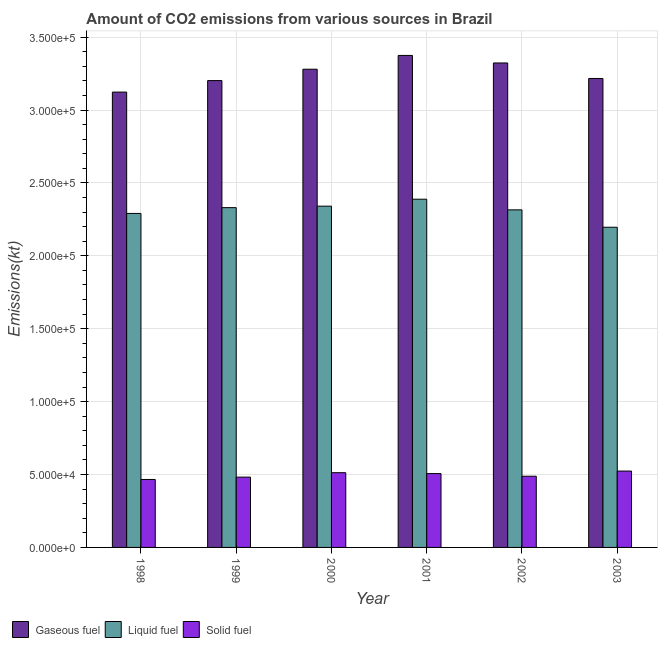Are the number of bars on each tick of the X-axis equal?
Provide a succinct answer. Yes. How many bars are there on the 3rd tick from the left?
Your answer should be compact. 3. In how many cases, is the number of bars for a given year not equal to the number of legend labels?
Offer a very short reply. 0. What is the amount of co2 emissions from solid fuel in 2001?
Give a very brief answer. 5.06e+04. Across all years, what is the maximum amount of co2 emissions from solid fuel?
Provide a succinct answer. 5.24e+04. Across all years, what is the minimum amount of co2 emissions from liquid fuel?
Ensure brevity in your answer.  2.20e+05. In which year was the amount of co2 emissions from gaseous fuel maximum?
Your answer should be very brief. 2001. What is the total amount of co2 emissions from solid fuel in the graph?
Make the answer very short. 2.98e+05. What is the difference between the amount of co2 emissions from solid fuel in 2000 and that in 2003?
Your answer should be compact. -1129.44. What is the difference between the amount of co2 emissions from gaseous fuel in 2000 and the amount of co2 emissions from solid fuel in 2001?
Your response must be concise. -9449.86. What is the average amount of co2 emissions from solid fuel per year?
Offer a terse response. 4.97e+04. In the year 2000, what is the difference between the amount of co2 emissions from liquid fuel and amount of co2 emissions from solid fuel?
Your response must be concise. 0. What is the ratio of the amount of co2 emissions from liquid fuel in 2000 to that in 2001?
Give a very brief answer. 0.98. Is the amount of co2 emissions from gaseous fuel in 2000 less than that in 2003?
Offer a very short reply. No. What is the difference between the highest and the second highest amount of co2 emissions from solid fuel?
Your response must be concise. 1129.44. What is the difference between the highest and the lowest amount of co2 emissions from liquid fuel?
Offer a very short reply. 1.92e+04. In how many years, is the amount of co2 emissions from gaseous fuel greater than the average amount of co2 emissions from gaseous fuel taken over all years?
Make the answer very short. 3. What does the 3rd bar from the left in 2002 represents?
Make the answer very short. Solid fuel. What does the 3rd bar from the right in 1998 represents?
Offer a very short reply. Gaseous fuel. How many bars are there?
Your answer should be very brief. 18. Are all the bars in the graph horizontal?
Your answer should be compact. No. Are the values on the major ticks of Y-axis written in scientific E-notation?
Keep it short and to the point. Yes. How many legend labels are there?
Provide a short and direct response. 3. What is the title of the graph?
Keep it short and to the point. Amount of CO2 emissions from various sources in Brazil. What is the label or title of the Y-axis?
Give a very brief answer. Emissions(kt). What is the Emissions(kt) in Gaseous fuel in 1998?
Provide a succinct answer. 3.12e+05. What is the Emissions(kt) of Liquid fuel in 1998?
Make the answer very short. 2.29e+05. What is the Emissions(kt) of Solid fuel in 1998?
Offer a very short reply. 4.66e+04. What is the Emissions(kt) in Gaseous fuel in 1999?
Make the answer very short. 3.20e+05. What is the Emissions(kt) of Liquid fuel in 1999?
Provide a short and direct response. 2.33e+05. What is the Emissions(kt) of Solid fuel in 1999?
Make the answer very short. 4.82e+04. What is the Emissions(kt) of Gaseous fuel in 2000?
Provide a succinct answer. 3.28e+05. What is the Emissions(kt) of Liquid fuel in 2000?
Your answer should be compact. 2.34e+05. What is the Emissions(kt) of Solid fuel in 2000?
Provide a succinct answer. 5.12e+04. What is the Emissions(kt) in Gaseous fuel in 2001?
Provide a short and direct response. 3.37e+05. What is the Emissions(kt) in Liquid fuel in 2001?
Provide a short and direct response. 2.39e+05. What is the Emissions(kt) in Solid fuel in 2001?
Offer a terse response. 5.06e+04. What is the Emissions(kt) of Gaseous fuel in 2002?
Your response must be concise. 3.32e+05. What is the Emissions(kt) of Liquid fuel in 2002?
Make the answer very short. 2.32e+05. What is the Emissions(kt) of Solid fuel in 2002?
Ensure brevity in your answer.  4.88e+04. What is the Emissions(kt) of Gaseous fuel in 2003?
Provide a succinct answer. 3.22e+05. What is the Emissions(kt) in Liquid fuel in 2003?
Ensure brevity in your answer.  2.20e+05. What is the Emissions(kt) of Solid fuel in 2003?
Make the answer very short. 5.24e+04. Across all years, what is the maximum Emissions(kt) of Gaseous fuel?
Your answer should be very brief. 3.37e+05. Across all years, what is the maximum Emissions(kt) of Liquid fuel?
Your response must be concise. 2.39e+05. Across all years, what is the maximum Emissions(kt) in Solid fuel?
Make the answer very short. 5.24e+04. Across all years, what is the minimum Emissions(kt) of Gaseous fuel?
Offer a very short reply. 3.12e+05. Across all years, what is the minimum Emissions(kt) in Liquid fuel?
Make the answer very short. 2.20e+05. Across all years, what is the minimum Emissions(kt) of Solid fuel?
Your answer should be compact. 4.66e+04. What is the total Emissions(kt) of Gaseous fuel in the graph?
Give a very brief answer. 1.95e+06. What is the total Emissions(kt) of Liquid fuel in the graph?
Your response must be concise. 1.39e+06. What is the total Emissions(kt) of Solid fuel in the graph?
Make the answer very short. 2.98e+05. What is the difference between the Emissions(kt) of Gaseous fuel in 1998 and that in 1999?
Give a very brief answer. -7884.05. What is the difference between the Emissions(kt) of Liquid fuel in 1998 and that in 1999?
Ensure brevity in your answer.  -3971.36. What is the difference between the Emissions(kt) in Solid fuel in 1998 and that in 1999?
Give a very brief answer. -1609.81. What is the difference between the Emissions(kt) of Gaseous fuel in 1998 and that in 2000?
Ensure brevity in your answer.  -1.57e+04. What is the difference between the Emissions(kt) in Liquid fuel in 1998 and that in 2000?
Keep it short and to the point. -4979.79. What is the difference between the Emissions(kt) in Solid fuel in 1998 and that in 2000?
Offer a very short reply. -4642.42. What is the difference between the Emissions(kt) in Gaseous fuel in 1998 and that in 2001?
Provide a short and direct response. -2.51e+04. What is the difference between the Emissions(kt) in Liquid fuel in 1998 and that in 2001?
Your response must be concise. -9754.22. What is the difference between the Emissions(kt) in Solid fuel in 1998 and that in 2001?
Keep it short and to the point. -4037.37. What is the difference between the Emissions(kt) of Gaseous fuel in 1998 and that in 2002?
Provide a succinct answer. -2.00e+04. What is the difference between the Emissions(kt) of Liquid fuel in 1998 and that in 2002?
Provide a short and direct response. -2449.56. What is the difference between the Emissions(kt) of Solid fuel in 1998 and that in 2002?
Make the answer very short. -2218.53. What is the difference between the Emissions(kt) of Gaseous fuel in 1998 and that in 2003?
Your answer should be very brief. -9332.51. What is the difference between the Emissions(kt) of Liquid fuel in 1998 and that in 2003?
Keep it short and to the point. 9471.86. What is the difference between the Emissions(kt) of Solid fuel in 1998 and that in 2003?
Your answer should be very brief. -5771.86. What is the difference between the Emissions(kt) of Gaseous fuel in 1999 and that in 2000?
Keep it short and to the point. -7810.71. What is the difference between the Emissions(kt) in Liquid fuel in 1999 and that in 2000?
Keep it short and to the point. -1008.42. What is the difference between the Emissions(kt) of Solid fuel in 1999 and that in 2000?
Your answer should be very brief. -3032.61. What is the difference between the Emissions(kt) in Gaseous fuel in 1999 and that in 2001?
Keep it short and to the point. -1.73e+04. What is the difference between the Emissions(kt) in Liquid fuel in 1999 and that in 2001?
Keep it short and to the point. -5782.86. What is the difference between the Emissions(kt) in Solid fuel in 1999 and that in 2001?
Make the answer very short. -2427.55. What is the difference between the Emissions(kt) of Gaseous fuel in 1999 and that in 2002?
Ensure brevity in your answer.  -1.21e+04. What is the difference between the Emissions(kt) of Liquid fuel in 1999 and that in 2002?
Your response must be concise. 1521.81. What is the difference between the Emissions(kt) in Solid fuel in 1999 and that in 2002?
Offer a terse response. -608.72. What is the difference between the Emissions(kt) in Gaseous fuel in 1999 and that in 2003?
Keep it short and to the point. -1448.46. What is the difference between the Emissions(kt) of Liquid fuel in 1999 and that in 2003?
Give a very brief answer. 1.34e+04. What is the difference between the Emissions(kt) of Solid fuel in 1999 and that in 2003?
Provide a short and direct response. -4162.05. What is the difference between the Emissions(kt) in Gaseous fuel in 2000 and that in 2001?
Your response must be concise. -9449.86. What is the difference between the Emissions(kt) in Liquid fuel in 2000 and that in 2001?
Offer a very short reply. -4774.43. What is the difference between the Emissions(kt) of Solid fuel in 2000 and that in 2001?
Give a very brief answer. 605.05. What is the difference between the Emissions(kt) in Gaseous fuel in 2000 and that in 2002?
Provide a succinct answer. -4283.06. What is the difference between the Emissions(kt) of Liquid fuel in 2000 and that in 2002?
Offer a terse response. 2530.23. What is the difference between the Emissions(kt) in Solid fuel in 2000 and that in 2002?
Make the answer very short. 2423.89. What is the difference between the Emissions(kt) in Gaseous fuel in 2000 and that in 2003?
Your response must be concise. 6362.24. What is the difference between the Emissions(kt) of Liquid fuel in 2000 and that in 2003?
Your answer should be compact. 1.45e+04. What is the difference between the Emissions(kt) of Solid fuel in 2000 and that in 2003?
Offer a terse response. -1129.44. What is the difference between the Emissions(kt) in Gaseous fuel in 2001 and that in 2002?
Offer a terse response. 5166.8. What is the difference between the Emissions(kt) in Liquid fuel in 2001 and that in 2002?
Give a very brief answer. 7304.66. What is the difference between the Emissions(kt) in Solid fuel in 2001 and that in 2002?
Provide a short and direct response. 1818.83. What is the difference between the Emissions(kt) in Gaseous fuel in 2001 and that in 2003?
Provide a short and direct response. 1.58e+04. What is the difference between the Emissions(kt) of Liquid fuel in 2001 and that in 2003?
Offer a very short reply. 1.92e+04. What is the difference between the Emissions(kt) of Solid fuel in 2001 and that in 2003?
Make the answer very short. -1734.49. What is the difference between the Emissions(kt) in Gaseous fuel in 2002 and that in 2003?
Your response must be concise. 1.06e+04. What is the difference between the Emissions(kt) of Liquid fuel in 2002 and that in 2003?
Offer a terse response. 1.19e+04. What is the difference between the Emissions(kt) of Solid fuel in 2002 and that in 2003?
Make the answer very short. -3553.32. What is the difference between the Emissions(kt) in Gaseous fuel in 1998 and the Emissions(kt) in Liquid fuel in 1999?
Your response must be concise. 7.93e+04. What is the difference between the Emissions(kt) of Gaseous fuel in 1998 and the Emissions(kt) of Solid fuel in 1999?
Offer a terse response. 2.64e+05. What is the difference between the Emissions(kt) of Liquid fuel in 1998 and the Emissions(kt) of Solid fuel in 1999?
Make the answer very short. 1.81e+05. What is the difference between the Emissions(kt) in Gaseous fuel in 1998 and the Emissions(kt) in Liquid fuel in 2000?
Provide a succinct answer. 7.82e+04. What is the difference between the Emissions(kt) of Gaseous fuel in 1998 and the Emissions(kt) of Solid fuel in 2000?
Your answer should be very brief. 2.61e+05. What is the difference between the Emissions(kt) of Liquid fuel in 1998 and the Emissions(kt) of Solid fuel in 2000?
Your answer should be compact. 1.78e+05. What is the difference between the Emissions(kt) in Gaseous fuel in 1998 and the Emissions(kt) in Liquid fuel in 2001?
Provide a short and direct response. 7.35e+04. What is the difference between the Emissions(kt) in Gaseous fuel in 1998 and the Emissions(kt) in Solid fuel in 2001?
Provide a short and direct response. 2.62e+05. What is the difference between the Emissions(kt) of Liquid fuel in 1998 and the Emissions(kt) of Solid fuel in 2001?
Your response must be concise. 1.78e+05. What is the difference between the Emissions(kt) in Gaseous fuel in 1998 and the Emissions(kt) in Liquid fuel in 2002?
Offer a terse response. 8.08e+04. What is the difference between the Emissions(kt) of Gaseous fuel in 1998 and the Emissions(kt) of Solid fuel in 2002?
Your answer should be compact. 2.63e+05. What is the difference between the Emissions(kt) of Liquid fuel in 1998 and the Emissions(kt) of Solid fuel in 2002?
Make the answer very short. 1.80e+05. What is the difference between the Emissions(kt) of Gaseous fuel in 1998 and the Emissions(kt) of Liquid fuel in 2003?
Ensure brevity in your answer.  9.27e+04. What is the difference between the Emissions(kt) of Gaseous fuel in 1998 and the Emissions(kt) of Solid fuel in 2003?
Provide a short and direct response. 2.60e+05. What is the difference between the Emissions(kt) of Liquid fuel in 1998 and the Emissions(kt) of Solid fuel in 2003?
Provide a short and direct response. 1.77e+05. What is the difference between the Emissions(kt) of Gaseous fuel in 1999 and the Emissions(kt) of Liquid fuel in 2000?
Keep it short and to the point. 8.61e+04. What is the difference between the Emissions(kt) in Gaseous fuel in 1999 and the Emissions(kt) in Solid fuel in 2000?
Ensure brevity in your answer.  2.69e+05. What is the difference between the Emissions(kt) in Liquid fuel in 1999 and the Emissions(kt) in Solid fuel in 2000?
Keep it short and to the point. 1.82e+05. What is the difference between the Emissions(kt) in Gaseous fuel in 1999 and the Emissions(kt) in Liquid fuel in 2001?
Ensure brevity in your answer.  8.14e+04. What is the difference between the Emissions(kt) in Gaseous fuel in 1999 and the Emissions(kt) in Solid fuel in 2001?
Keep it short and to the point. 2.70e+05. What is the difference between the Emissions(kt) in Liquid fuel in 1999 and the Emissions(kt) in Solid fuel in 2001?
Offer a terse response. 1.82e+05. What is the difference between the Emissions(kt) of Gaseous fuel in 1999 and the Emissions(kt) of Liquid fuel in 2002?
Provide a succinct answer. 8.87e+04. What is the difference between the Emissions(kt) of Gaseous fuel in 1999 and the Emissions(kt) of Solid fuel in 2002?
Your answer should be very brief. 2.71e+05. What is the difference between the Emissions(kt) of Liquid fuel in 1999 and the Emissions(kt) of Solid fuel in 2002?
Offer a very short reply. 1.84e+05. What is the difference between the Emissions(kt) of Gaseous fuel in 1999 and the Emissions(kt) of Liquid fuel in 2003?
Offer a very short reply. 1.01e+05. What is the difference between the Emissions(kt) of Gaseous fuel in 1999 and the Emissions(kt) of Solid fuel in 2003?
Your answer should be very brief. 2.68e+05. What is the difference between the Emissions(kt) of Liquid fuel in 1999 and the Emissions(kt) of Solid fuel in 2003?
Keep it short and to the point. 1.81e+05. What is the difference between the Emissions(kt) in Gaseous fuel in 2000 and the Emissions(kt) in Liquid fuel in 2001?
Keep it short and to the point. 8.92e+04. What is the difference between the Emissions(kt) in Gaseous fuel in 2000 and the Emissions(kt) in Solid fuel in 2001?
Provide a succinct answer. 2.77e+05. What is the difference between the Emissions(kt) in Liquid fuel in 2000 and the Emissions(kt) in Solid fuel in 2001?
Give a very brief answer. 1.83e+05. What is the difference between the Emissions(kt) in Gaseous fuel in 2000 and the Emissions(kt) in Liquid fuel in 2002?
Make the answer very short. 9.65e+04. What is the difference between the Emissions(kt) of Gaseous fuel in 2000 and the Emissions(kt) of Solid fuel in 2002?
Give a very brief answer. 2.79e+05. What is the difference between the Emissions(kt) of Liquid fuel in 2000 and the Emissions(kt) of Solid fuel in 2002?
Your answer should be compact. 1.85e+05. What is the difference between the Emissions(kt) in Gaseous fuel in 2000 and the Emissions(kt) in Liquid fuel in 2003?
Provide a succinct answer. 1.08e+05. What is the difference between the Emissions(kt) in Gaseous fuel in 2000 and the Emissions(kt) in Solid fuel in 2003?
Give a very brief answer. 2.76e+05. What is the difference between the Emissions(kt) in Liquid fuel in 2000 and the Emissions(kt) in Solid fuel in 2003?
Your response must be concise. 1.82e+05. What is the difference between the Emissions(kt) of Gaseous fuel in 2001 and the Emissions(kt) of Liquid fuel in 2002?
Offer a terse response. 1.06e+05. What is the difference between the Emissions(kt) in Gaseous fuel in 2001 and the Emissions(kt) in Solid fuel in 2002?
Your response must be concise. 2.89e+05. What is the difference between the Emissions(kt) in Liquid fuel in 2001 and the Emissions(kt) in Solid fuel in 2002?
Keep it short and to the point. 1.90e+05. What is the difference between the Emissions(kt) of Gaseous fuel in 2001 and the Emissions(kt) of Liquid fuel in 2003?
Your response must be concise. 1.18e+05. What is the difference between the Emissions(kt) of Gaseous fuel in 2001 and the Emissions(kt) of Solid fuel in 2003?
Offer a very short reply. 2.85e+05. What is the difference between the Emissions(kt) of Liquid fuel in 2001 and the Emissions(kt) of Solid fuel in 2003?
Provide a succinct answer. 1.86e+05. What is the difference between the Emissions(kt) of Gaseous fuel in 2002 and the Emissions(kt) of Liquid fuel in 2003?
Your response must be concise. 1.13e+05. What is the difference between the Emissions(kt) of Gaseous fuel in 2002 and the Emissions(kt) of Solid fuel in 2003?
Provide a short and direct response. 2.80e+05. What is the difference between the Emissions(kt) of Liquid fuel in 2002 and the Emissions(kt) of Solid fuel in 2003?
Provide a short and direct response. 1.79e+05. What is the average Emissions(kt) of Gaseous fuel per year?
Provide a succinct answer. 3.25e+05. What is the average Emissions(kt) in Liquid fuel per year?
Provide a succinct answer. 2.31e+05. What is the average Emissions(kt) in Solid fuel per year?
Provide a short and direct response. 4.97e+04. In the year 1998, what is the difference between the Emissions(kt) of Gaseous fuel and Emissions(kt) of Liquid fuel?
Your response must be concise. 8.32e+04. In the year 1998, what is the difference between the Emissions(kt) of Gaseous fuel and Emissions(kt) of Solid fuel?
Ensure brevity in your answer.  2.66e+05. In the year 1998, what is the difference between the Emissions(kt) in Liquid fuel and Emissions(kt) in Solid fuel?
Give a very brief answer. 1.82e+05. In the year 1999, what is the difference between the Emissions(kt) in Gaseous fuel and Emissions(kt) in Liquid fuel?
Your response must be concise. 8.71e+04. In the year 1999, what is the difference between the Emissions(kt) of Gaseous fuel and Emissions(kt) of Solid fuel?
Offer a terse response. 2.72e+05. In the year 1999, what is the difference between the Emissions(kt) in Liquid fuel and Emissions(kt) in Solid fuel?
Give a very brief answer. 1.85e+05. In the year 2000, what is the difference between the Emissions(kt) in Gaseous fuel and Emissions(kt) in Liquid fuel?
Provide a short and direct response. 9.39e+04. In the year 2000, what is the difference between the Emissions(kt) of Gaseous fuel and Emissions(kt) of Solid fuel?
Provide a succinct answer. 2.77e+05. In the year 2000, what is the difference between the Emissions(kt) in Liquid fuel and Emissions(kt) in Solid fuel?
Keep it short and to the point. 1.83e+05. In the year 2001, what is the difference between the Emissions(kt) in Gaseous fuel and Emissions(kt) in Liquid fuel?
Make the answer very short. 9.86e+04. In the year 2001, what is the difference between the Emissions(kt) in Gaseous fuel and Emissions(kt) in Solid fuel?
Offer a terse response. 2.87e+05. In the year 2001, what is the difference between the Emissions(kt) of Liquid fuel and Emissions(kt) of Solid fuel?
Make the answer very short. 1.88e+05. In the year 2002, what is the difference between the Emissions(kt) in Gaseous fuel and Emissions(kt) in Liquid fuel?
Your response must be concise. 1.01e+05. In the year 2002, what is the difference between the Emissions(kt) of Gaseous fuel and Emissions(kt) of Solid fuel?
Make the answer very short. 2.83e+05. In the year 2002, what is the difference between the Emissions(kt) in Liquid fuel and Emissions(kt) in Solid fuel?
Your answer should be very brief. 1.83e+05. In the year 2003, what is the difference between the Emissions(kt) of Gaseous fuel and Emissions(kt) of Liquid fuel?
Give a very brief answer. 1.02e+05. In the year 2003, what is the difference between the Emissions(kt) of Gaseous fuel and Emissions(kt) of Solid fuel?
Provide a succinct answer. 2.69e+05. In the year 2003, what is the difference between the Emissions(kt) in Liquid fuel and Emissions(kt) in Solid fuel?
Offer a very short reply. 1.67e+05. What is the ratio of the Emissions(kt) of Gaseous fuel in 1998 to that in 1999?
Your answer should be compact. 0.98. What is the ratio of the Emissions(kt) of Liquid fuel in 1998 to that in 1999?
Your answer should be compact. 0.98. What is the ratio of the Emissions(kt) of Solid fuel in 1998 to that in 1999?
Your answer should be compact. 0.97. What is the ratio of the Emissions(kt) in Gaseous fuel in 1998 to that in 2000?
Provide a short and direct response. 0.95. What is the ratio of the Emissions(kt) in Liquid fuel in 1998 to that in 2000?
Make the answer very short. 0.98. What is the ratio of the Emissions(kt) in Solid fuel in 1998 to that in 2000?
Ensure brevity in your answer.  0.91. What is the ratio of the Emissions(kt) in Gaseous fuel in 1998 to that in 2001?
Provide a succinct answer. 0.93. What is the ratio of the Emissions(kt) in Liquid fuel in 1998 to that in 2001?
Give a very brief answer. 0.96. What is the ratio of the Emissions(kt) of Solid fuel in 1998 to that in 2001?
Your answer should be compact. 0.92. What is the ratio of the Emissions(kt) of Gaseous fuel in 1998 to that in 2002?
Give a very brief answer. 0.94. What is the ratio of the Emissions(kt) in Solid fuel in 1998 to that in 2002?
Ensure brevity in your answer.  0.95. What is the ratio of the Emissions(kt) in Gaseous fuel in 1998 to that in 2003?
Your response must be concise. 0.97. What is the ratio of the Emissions(kt) of Liquid fuel in 1998 to that in 2003?
Provide a succinct answer. 1.04. What is the ratio of the Emissions(kt) of Solid fuel in 1998 to that in 2003?
Your response must be concise. 0.89. What is the ratio of the Emissions(kt) in Gaseous fuel in 1999 to that in 2000?
Your answer should be compact. 0.98. What is the ratio of the Emissions(kt) of Solid fuel in 1999 to that in 2000?
Keep it short and to the point. 0.94. What is the ratio of the Emissions(kt) in Gaseous fuel in 1999 to that in 2001?
Provide a succinct answer. 0.95. What is the ratio of the Emissions(kt) in Liquid fuel in 1999 to that in 2001?
Give a very brief answer. 0.98. What is the ratio of the Emissions(kt) in Solid fuel in 1999 to that in 2001?
Offer a terse response. 0.95. What is the ratio of the Emissions(kt) in Gaseous fuel in 1999 to that in 2002?
Provide a short and direct response. 0.96. What is the ratio of the Emissions(kt) in Liquid fuel in 1999 to that in 2002?
Make the answer very short. 1.01. What is the ratio of the Emissions(kt) of Solid fuel in 1999 to that in 2002?
Ensure brevity in your answer.  0.99. What is the ratio of the Emissions(kt) of Liquid fuel in 1999 to that in 2003?
Keep it short and to the point. 1.06. What is the ratio of the Emissions(kt) of Solid fuel in 1999 to that in 2003?
Give a very brief answer. 0.92. What is the ratio of the Emissions(kt) in Liquid fuel in 2000 to that in 2001?
Your response must be concise. 0.98. What is the ratio of the Emissions(kt) in Solid fuel in 2000 to that in 2001?
Your answer should be compact. 1.01. What is the ratio of the Emissions(kt) in Gaseous fuel in 2000 to that in 2002?
Offer a very short reply. 0.99. What is the ratio of the Emissions(kt) of Liquid fuel in 2000 to that in 2002?
Provide a succinct answer. 1.01. What is the ratio of the Emissions(kt) in Solid fuel in 2000 to that in 2002?
Ensure brevity in your answer.  1.05. What is the ratio of the Emissions(kt) in Gaseous fuel in 2000 to that in 2003?
Make the answer very short. 1.02. What is the ratio of the Emissions(kt) of Liquid fuel in 2000 to that in 2003?
Your answer should be compact. 1.07. What is the ratio of the Emissions(kt) of Solid fuel in 2000 to that in 2003?
Offer a very short reply. 0.98. What is the ratio of the Emissions(kt) in Gaseous fuel in 2001 to that in 2002?
Offer a very short reply. 1.02. What is the ratio of the Emissions(kt) of Liquid fuel in 2001 to that in 2002?
Make the answer very short. 1.03. What is the ratio of the Emissions(kt) in Solid fuel in 2001 to that in 2002?
Your response must be concise. 1.04. What is the ratio of the Emissions(kt) of Gaseous fuel in 2001 to that in 2003?
Offer a very short reply. 1.05. What is the ratio of the Emissions(kt) in Liquid fuel in 2001 to that in 2003?
Give a very brief answer. 1.09. What is the ratio of the Emissions(kt) of Solid fuel in 2001 to that in 2003?
Provide a short and direct response. 0.97. What is the ratio of the Emissions(kt) in Gaseous fuel in 2002 to that in 2003?
Provide a short and direct response. 1.03. What is the ratio of the Emissions(kt) of Liquid fuel in 2002 to that in 2003?
Ensure brevity in your answer.  1.05. What is the ratio of the Emissions(kt) in Solid fuel in 2002 to that in 2003?
Your answer should be very brief. 0.93. What is the difference between the highest and the second highest Emissions(kt) of Gaseous fuel?
Offer a terse response. 5166.8. What is the difference between the highest and the second highest Emissions(kt) in Liquid fuel?
Keep it short and to the point. 4774.43. What is the difference between the highest and the second highest Emissions(kt) in Solid fuel?
Keep it short and to the point. 1129.44. What is the difference between the highest and the lowest Emissions(kt) in Gaseous fuel?
Offer a terse response. 2.51e+04. What is the difference between the highest and the lowest Emissions(kt) in Liquid fuel?
Ensure brevity in your answer.  1.92e+04. What is the difference between the highest and the lowest Emissions(kt) of Solid fuel?
Provide a short and direct response. 5771.86. 